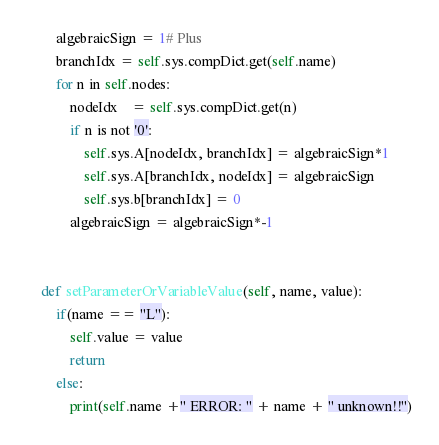Convert code to text. <code><loc_0><loc_0><loc_500><loc_500><_Python_>        algebraicSign = 1# Plus
        branchIdx = self.sys.compDict.get(self.name)
        for n in self.nodes:
            nodeIdx    = self.sys.compDict.get(n)
            if n is not '0':
                self.sys.A[nodeIdx, branchIdx] = algebraicSign*1
                self.sys.A[branchIdx, nodeIdx] = algebraicSign
                self.sys.b[branchIdx] = 0
            algebraicSign = algebraicSign*-1


    def setParameterOrVariableValue(self, name, value):
        if(name == "L"):
            self.value = value
            return
        else:
            print(self.name +" ERROR: " + name + " unknown!!")

</code> 